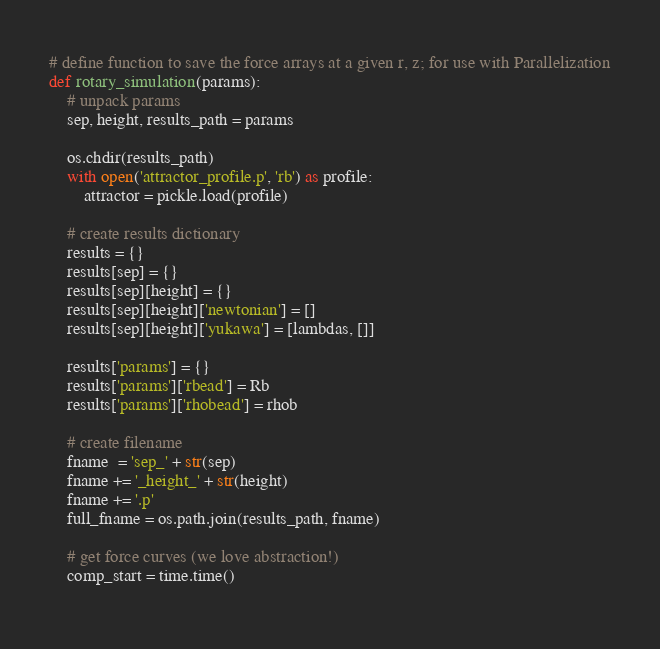Convert code to text. <code><loc_0><loc_0><loc_500><loc_500><_Python_># define function to save the force arrays at a given r, z; for use with Parallelization
def rotary_simulation(params):
    # unpack params
    sep, height, results_path = params
    
    os.chdir(results_path)
    with open('attractor_profile.p', 'rb') as profile:
        attractor = pickle.load(profile)

    # create results dictionary
    results = {}
    results[sep] = {}
    results[sep][height] = {}
    results[sep][height]['newtonian'] = []
    results[sep][height]['yukawa'] = [lambdas, []]

    results['params'] = {}
    results['params']['rbead'] = Rb
    results['params']['rhobead'] = rhob

    # create filename
    fname  = 'sep_' + str(sep)
    fname += '_height_' + str(height)
    fname += '.p'
    full_fname = os.path.join(results_path, fname)

    # get force curves (we love abstraction!)
    comp_start = time.time()
    </code> 